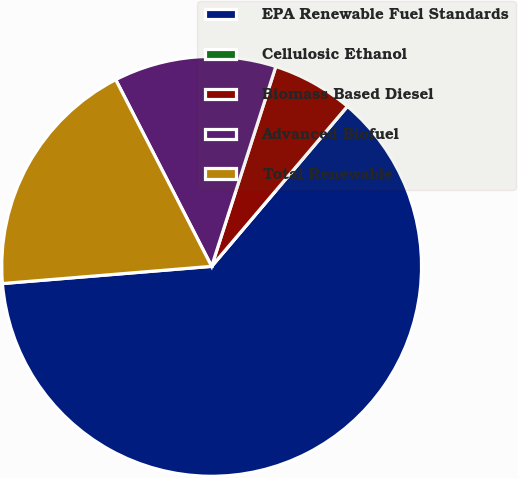Convert chart. <chart><loc_0><loc_0><loc_500><loc_500><pie_chart><fcel>EPA Renewable Fuel Standards<fcel>Cellulosic Ethanol<fcel>Biomass Based Diesel<fcel>Advanced Biofuel<fcel>Total Renewable<nl><fcel>62.5%<fcel>0.0%<fcel>6.25%<fcel>12.5%<fcel>18.75%<nl></chart> 